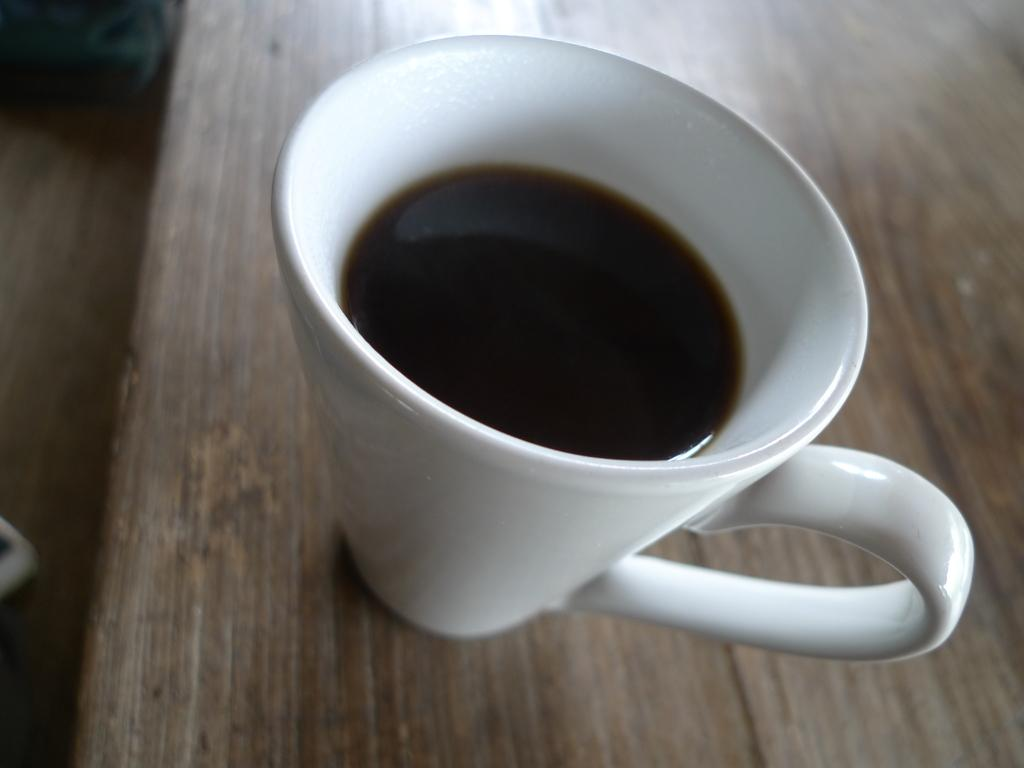What is the main object in the center of the image? There is a white coffee mug in the center of the image. What is inside the coffee mug? The mug contains a liquid. On what surface is the coffee mug placed? The mug is placed on a wooden table. What can be seen on the left side of the image? There are objects on the left side of the image. Where is the toothbrush being used for teaching in the image? There is no toothbrush or teaching activity present in the image. 